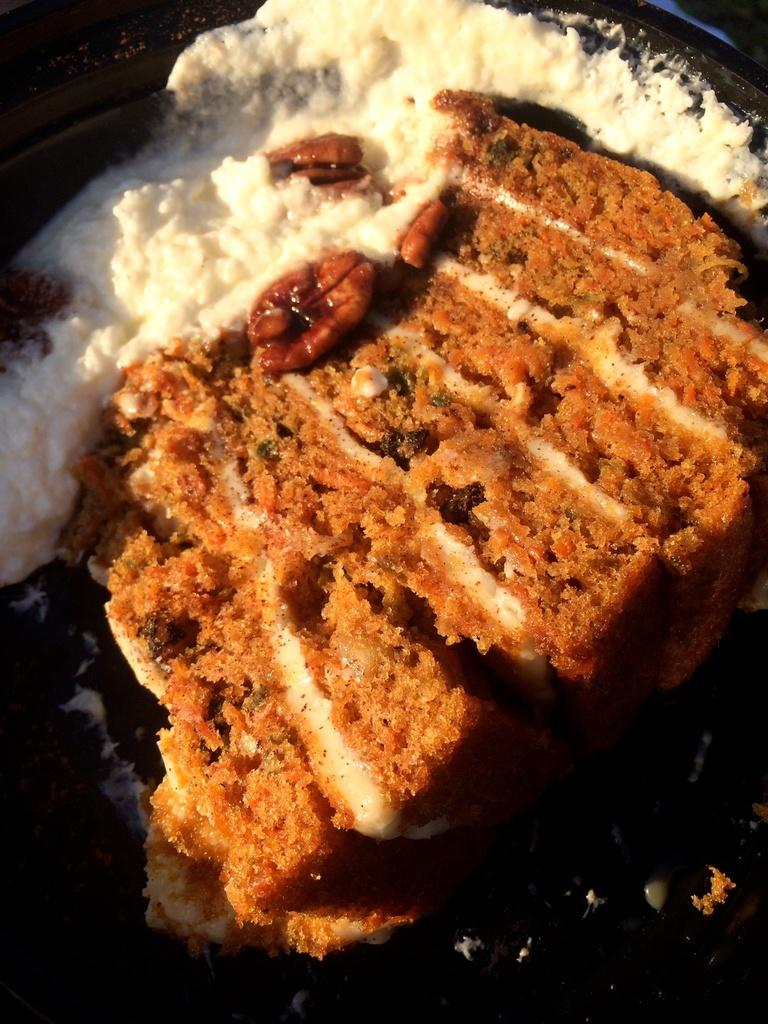What can be seen in the image related to food? There is some food visible in the image. What type of bear can be seen interacting with the food in the image? There is no bear present in the image, and therefore no interaction with the food can be observed. 